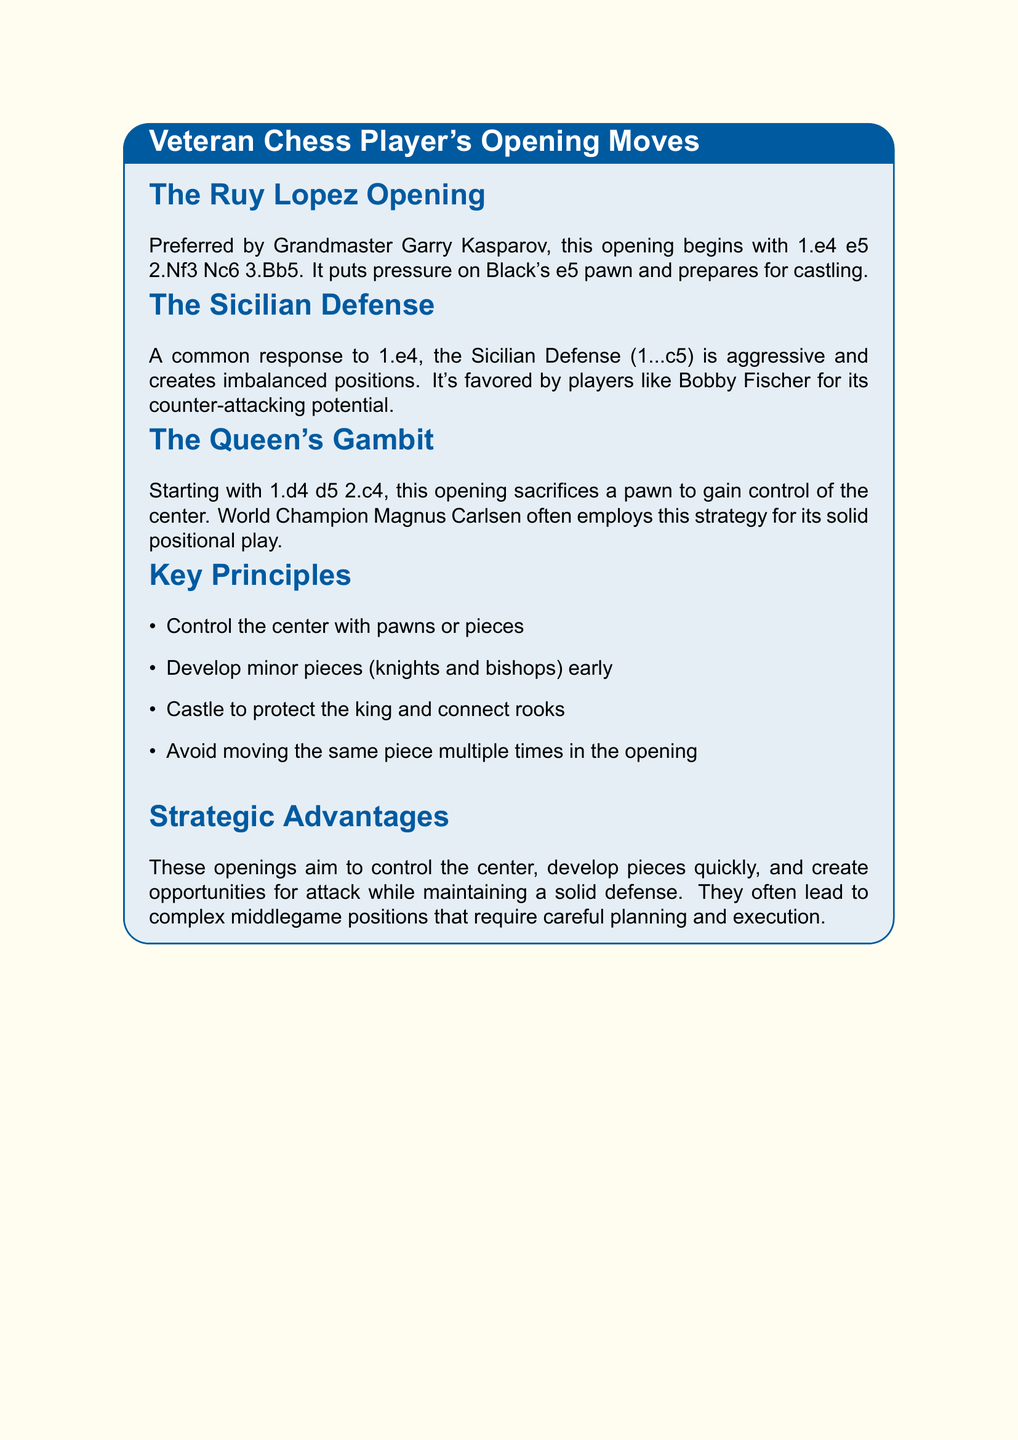What is the first move in the Ruy Lopez Opening? The Ruy Lopez Opening starts with 1.e4 e5, followed by 2.Nf3 Nc6 3.Bb5.
Answer: 1.e4 e5 Who is a noted player for the Sicilian Defense? The Sicilian Defense is favored by players like Bobby Fischer for its counter-attacking potential.
Answer: Bobby Fischer What is the initial move in the Queen's Gambit? The Queen's Gambit starts with 1.d4 d5, followed by 2.c4.
Answer: 1.d4 d5 What is one key principle mentioned in the notes? One principle is to control the center with pawns or pieces.
Answer: Control the center with pawns or pieces Which opening sacrifices a pawn for center control? The Queen's Gambit sacrifices a pawn to gain control of the center.
Answer: The Queen's Gambit What is the strategic goal of these openings? The strategic goal is to control the center, develop pieces quickly, and create opportunities for attack.
Answer: Control the center, develop pieces quickly, and create opportunities for attack Who preferred the Ruy Lopez Opening? Grandmaster Garry Kasparov preferred the Ruy Lopez Opening.
Answer: Garry Kasparov How many key principles are listed in the notes? The notes list four key principles for opening moves.
Answer: Four 